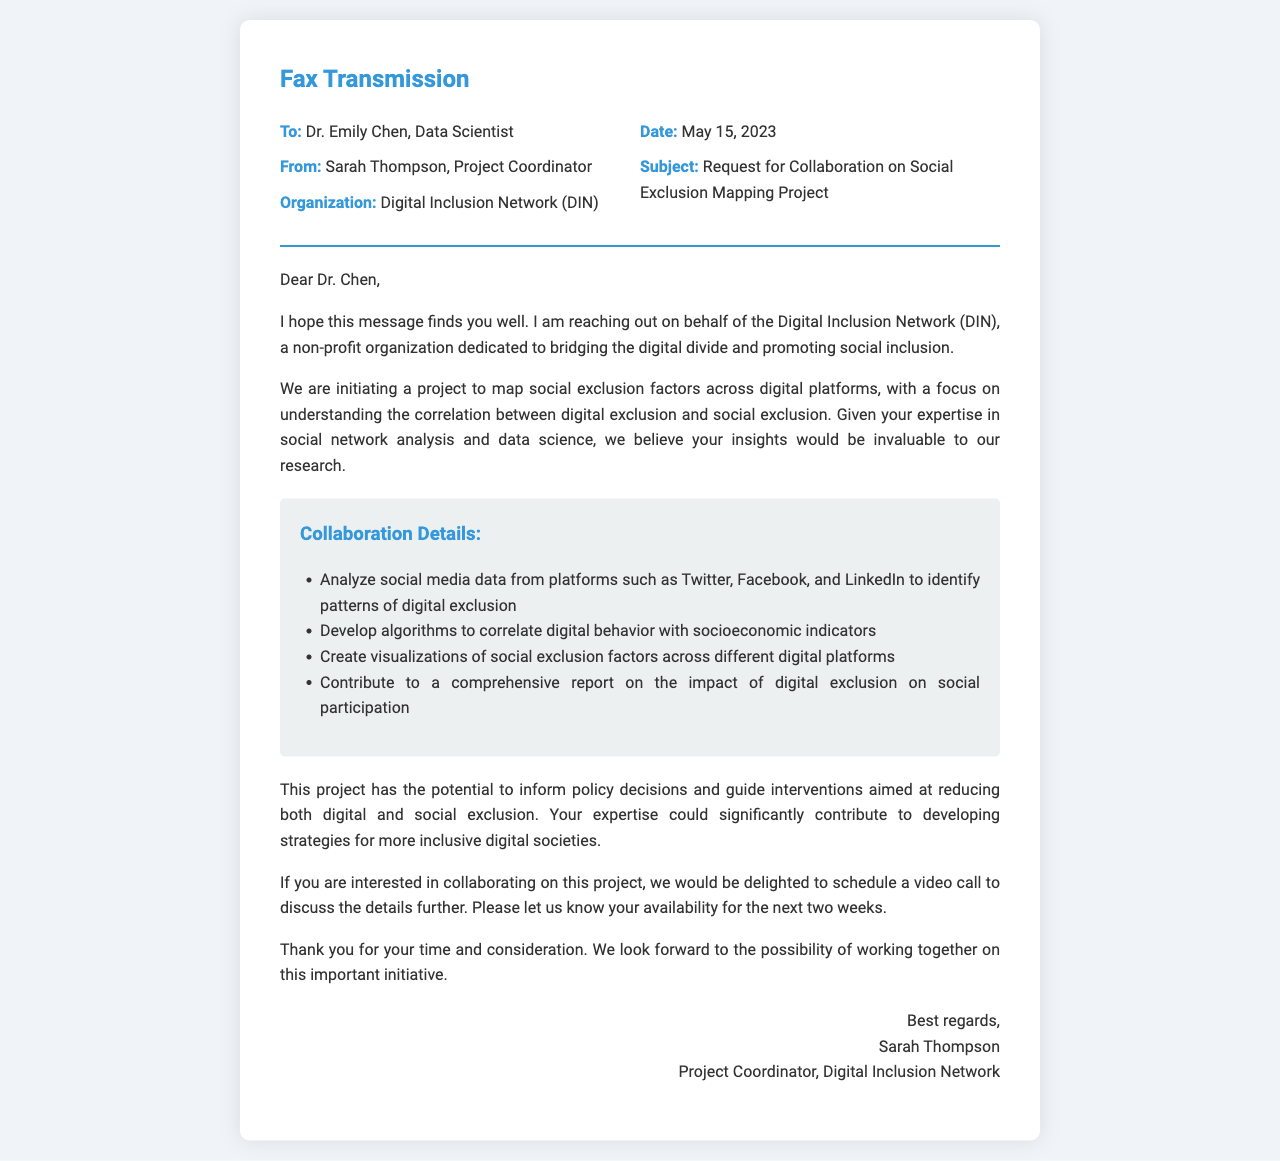What is the name of the organization sending the fax? The organization sending the fax is mentioned in the "From" section, which lists it as the Digital Inclusion Network (DIN).
Answer: Digital Inclusion Network (DIN) Who is the recipient of the fax? The recipient's name is stated in the "To" section, which identifies them as Dr. Emily Chen, Data Scientist.
Answer: Dr. Emily Chen What is the subject of the fax? The subject is explicitly stated in the document as "Request for Collaboration on Social Exclusion Mapping Project".
Answer: Request for Collaboration on Social Exclusion Mapping Project What date was the fax sent? The date is provided in the "Date" section, which is May 15, 2023.
Answer: May 15, 2023 What type of collaboration is DIN seeking? The collaboration type can be inferred from the project description, focusing on mapping social exclusion factors across digital platforms.
Answer: Mapping social exclusion factors across digital platforms How many weeks is the organization asking to discuss further? The document suggests scheduling a video call and mentions asking for availability for the next two weeks.
Answer: Two weeks What is one specific digital platform mentioned in the collaboration details? The collaboration details include a list of digital platforms, one of which is Twitter.
Answer: Twitter What is the role of the person sending the fax? The sender's role is stated in the closing section of the fax, indicating they are the Project Coordinator.
Answer: Project Coordinator What does DIN aim to inform through this project? DIN aims to inform policy decisions and guide interventions related to digital and social exclusion based on the project goals outlined in the content.
Answer: Policy decisions 